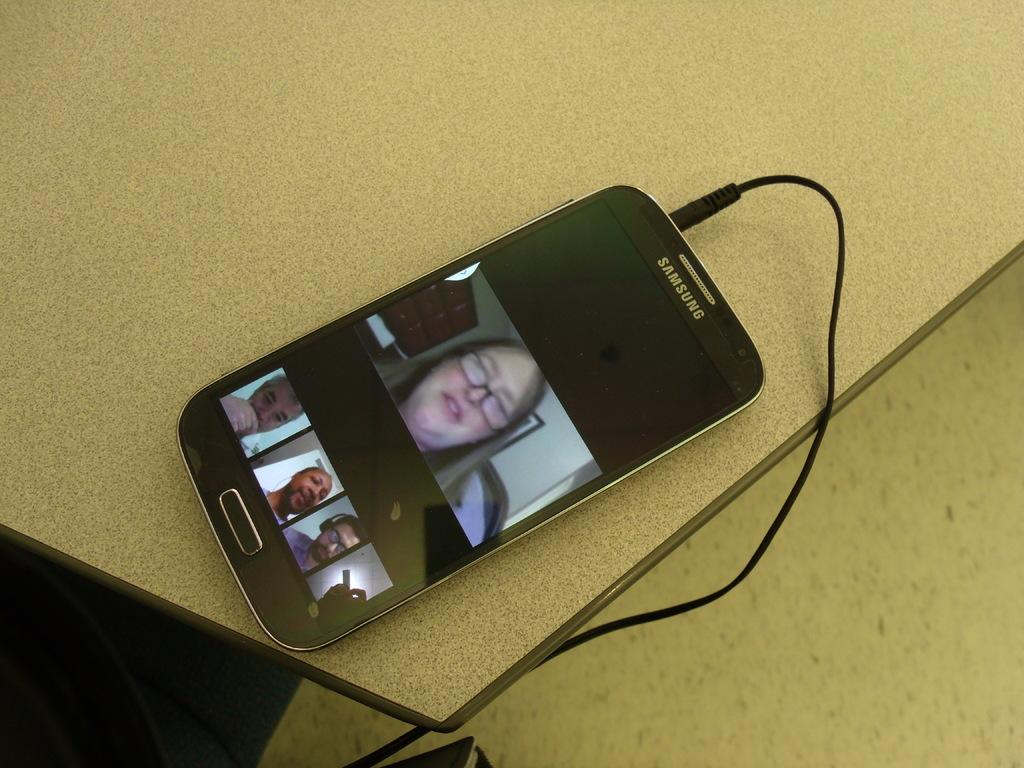What is the main object in the center of the image? There is a table in the center of the image. What is placed on the table? A mobile is present on the table. Are there any additional items on the table? Yes, there are wires on the table. What can be seen at the bottom of the image? The floor is visible at the bottom of the image. Can you see the sea in the image? No, there is no sea visible in the image. The image features a table, a mobile, wires, and a floor, but no body of water. 